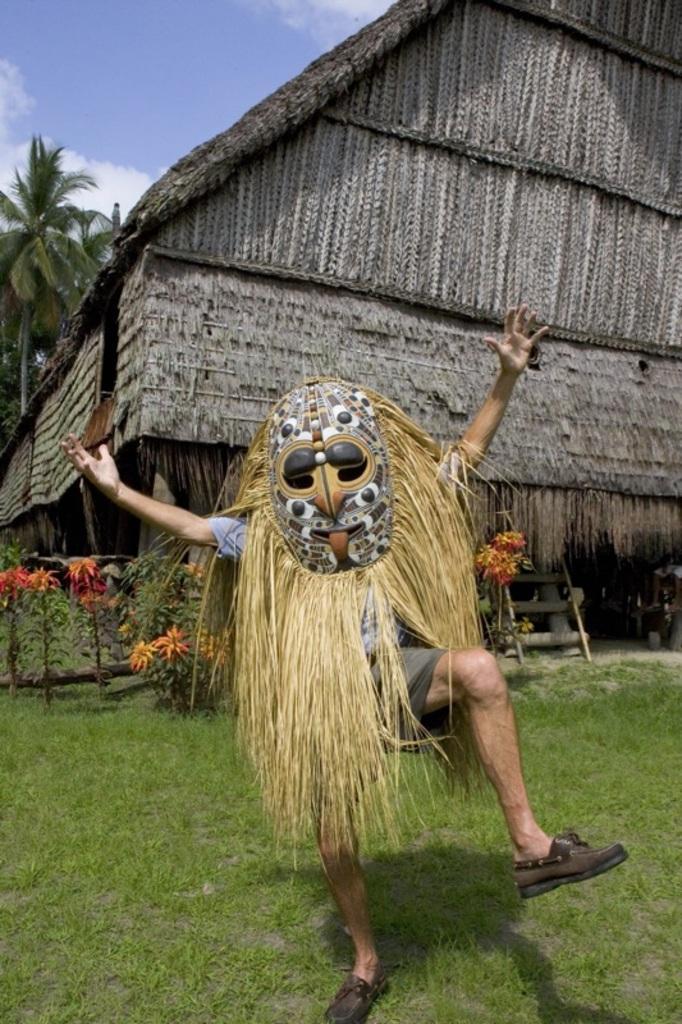How would you summarize this image in a sentence or two? In this image there is a person wearing mask and he is dancing on the surface of the grass, beside him there are plants and flowers. In the background there is a hut, trees and a sky. 